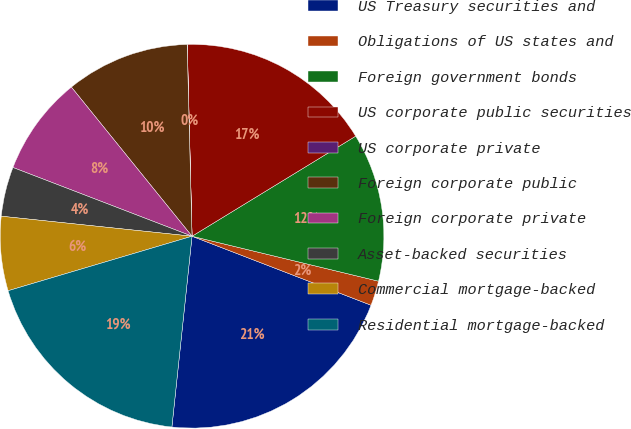Convert chart to OTSL. <chart><loc_0><loc_0><loc_500><loc_500><pie_chart><fcel>US Treasury securities and<fcel>Obligations of US states and<fcel>Foreign government bonds<fcel>US corporate public securities<fcel>US corporate private<fcel>Foreign corporate public<fcel>Foreign corporate private<fcel>Asset-backed securities<fcel>Commercial mortgage-backed<fcel>Residential mortgage-backed<nl><fcel>20.82%<fcel>2.09%<fcel>12.5%<fcel>16.66%<fcel>0.01%<fcel>10.42%<fcel>8.34%<fcel>4.17%<fcel>6.25%<fcel>18.74%<nl></chart> 